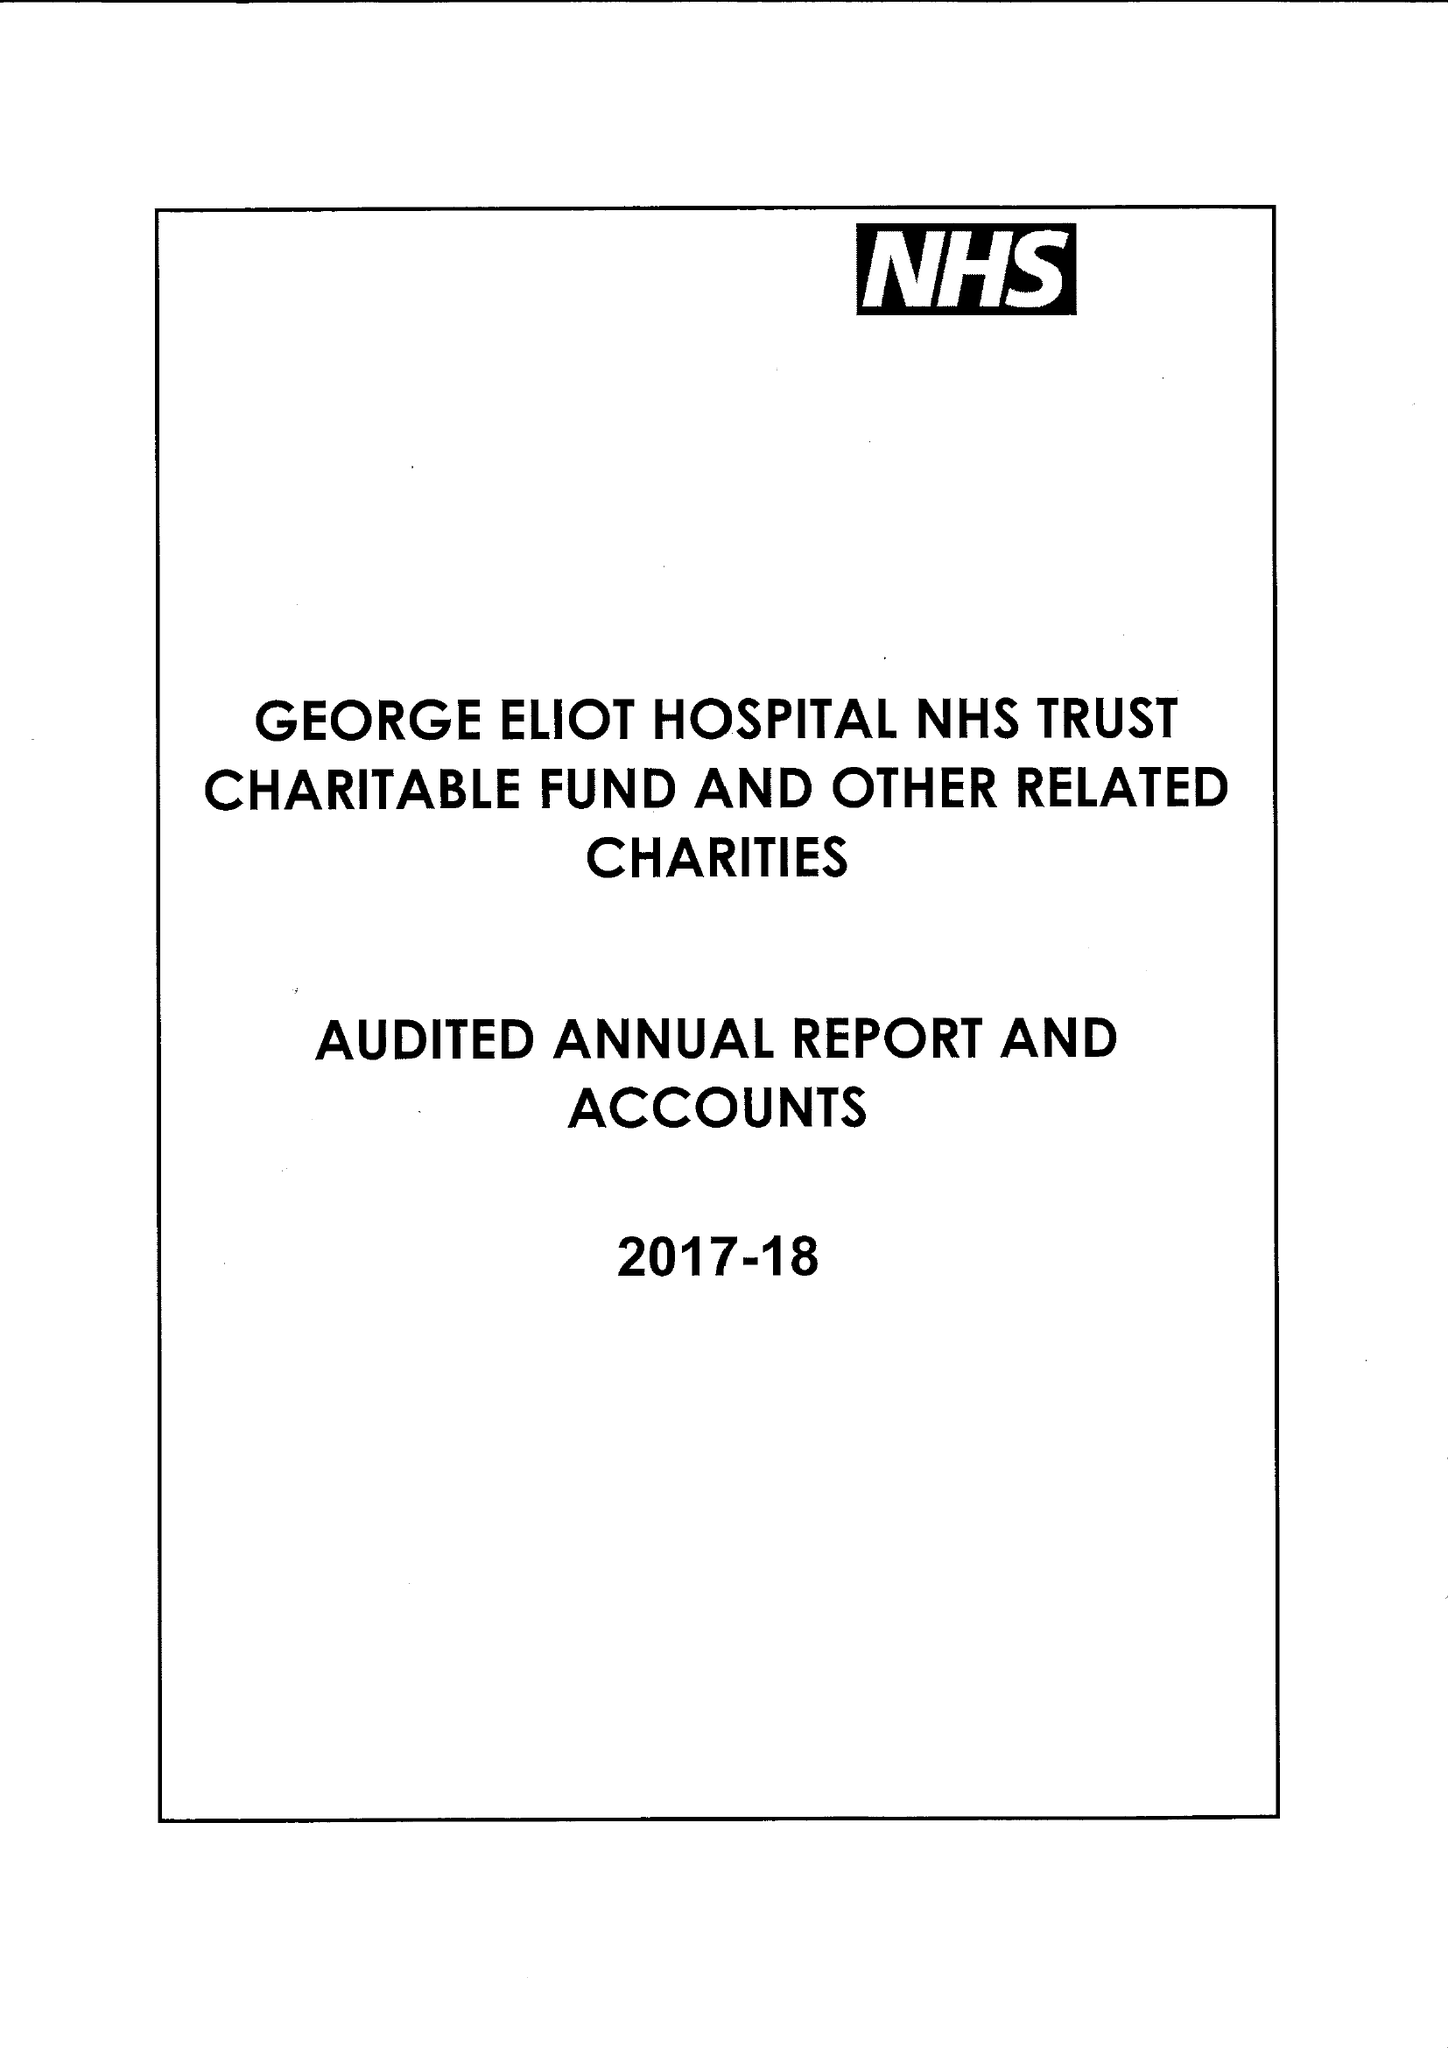What is the value for the address__post_town?
Answer the question using a single word or phrase. NUNEATON 